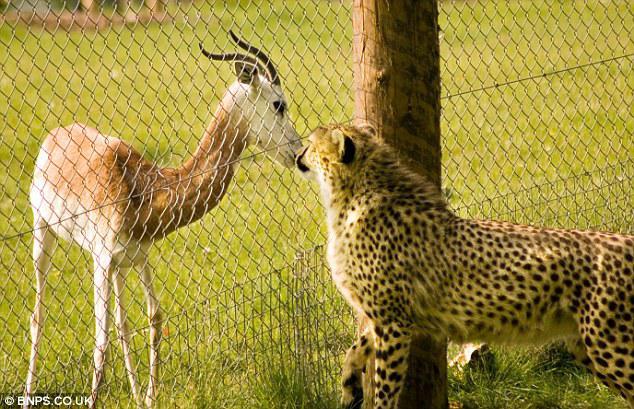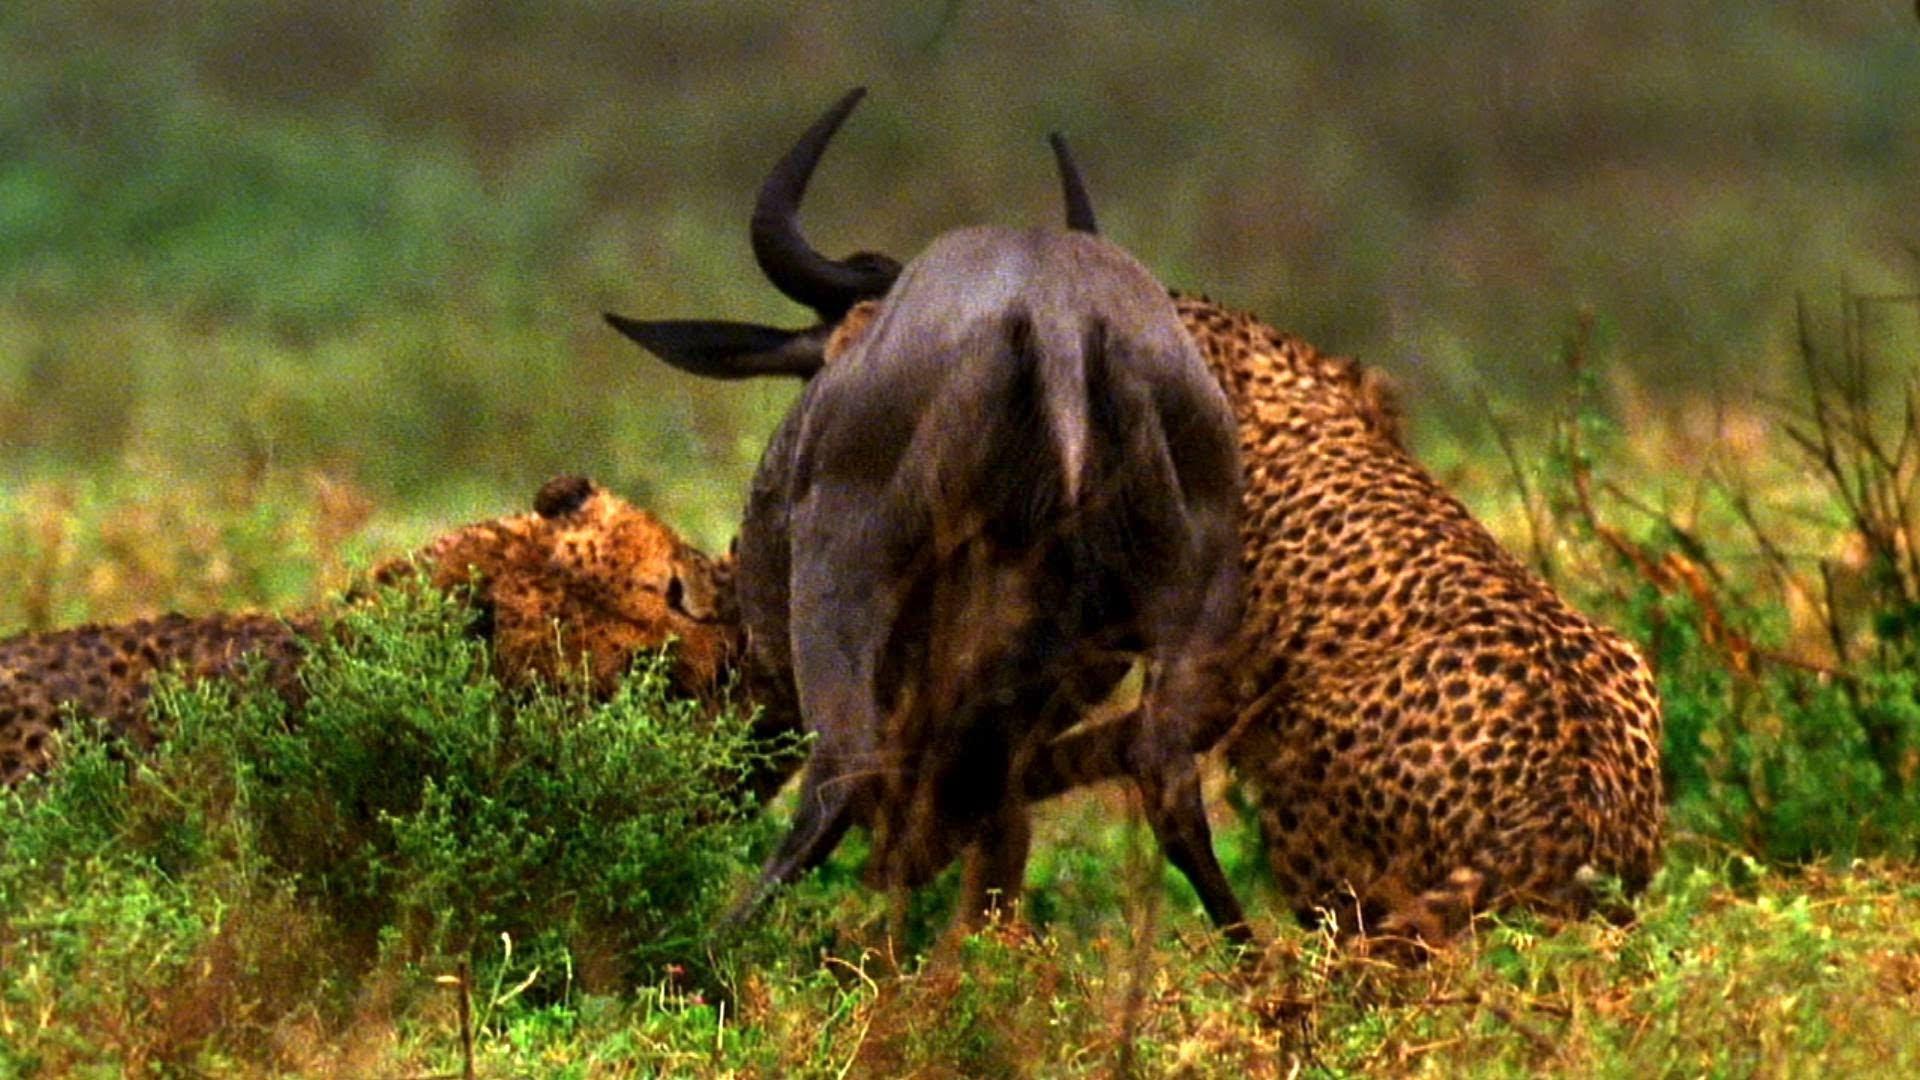The first image is the image on the left, the second image is the image on the right. Given the left and right images, does the statement "An image shows one cheetah bounding with front paws extended." hold true? Answer yes or no. No. The first image is the image on the left, the second image is the image on the right. Analyze the images presented: Is the assertion "There are four cheetas shown" valid? Answer yes or no. No. 